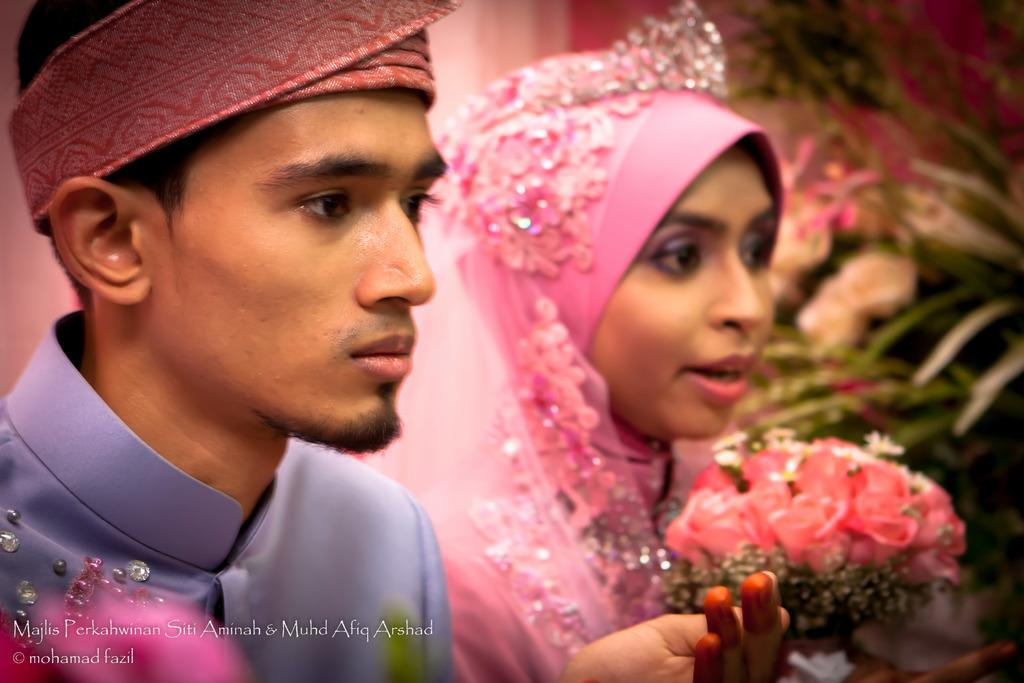How many people are in the image? There is a man and a woman in the image. What objects can be seen in the image besides the people? There is a bouquet and a plant in a pot in the image. Can you see a kitten playing in the ocean in the image? No, there is no kitten or ocean present in the image. 